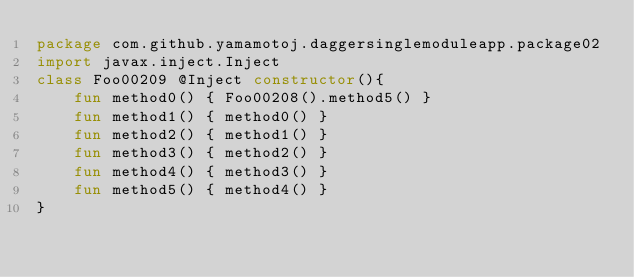<code> <loc_0><loc_0><loc_500><loc_500><_Kotlin_>package com.github.yamamotoj.daggersinglemoduleapp.package02
import javax.inject.Inject
class Foo00209 @Inject constructor(){
    fun method0() { Foo00208().method5() }
    fun method1() { method0() }
    fun method2() { method1() }
    fun method3() { method2() }
    fun method4() { method3() }
    fun method5() { method4() }
}
</code> 